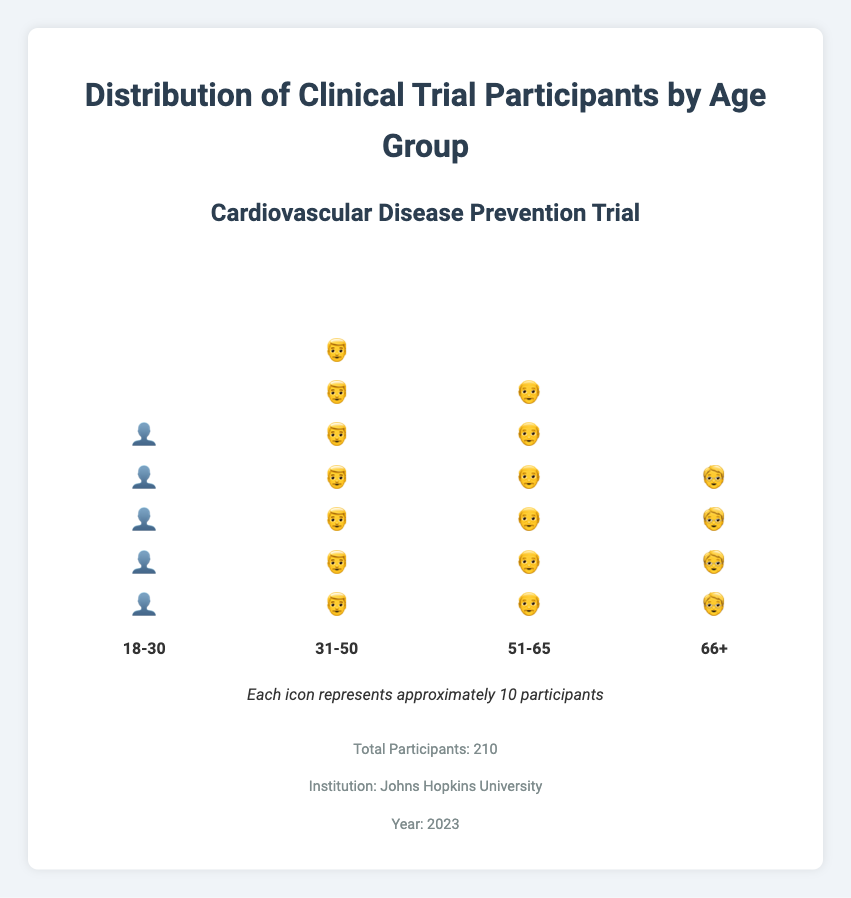What is the title of the figure? The title of the figure is located at the top and is clearly indicated by larger and bold text.
Answer: Distribution of Clinical Trial Participants by Age Group Which institution conducted the study? The information about the institution is provided at the bottom of the figure in the study info section.
Answer: Johns Hopkins University How many age groups are represented in the figure? By counting the distinct sets of icons and group labels at the bottom, you can see there are four age groups.
Answer: Four What icon represents the 31-50 age group? By looking at the icon within the stack under the 31-50 label, the icon representing this group is a human figure with the appearance of an adult male.
Answer: 👨 Which age group has the highest number of participants? Observing the tallest stack of icons and referring to the group label, the 31-50 age group has the highest number of icons.
Answer: 31-50 What is the total number of participants in the age group 18-30? The legend indicates each icon represents about 10 participants. Counting the 18-30 icons (5), each representing about 10, gives a total.
Answer: 50 How many more participants are there in the group 31-50 compared to the group 66+? The 31-50 group has 72 participants, and the 66+ group has 35 participants. The difference is calculated as 72 - 35.
Answer: 37 What percentage of participants are in the group 51-65? Divide the number of participants in the 51-65 group (58) by the total participants (210) and multiply by 100 to get the percentage.
Answer: 27.62% How does the number of participants in the 18-30 group compare to the 51-65 group? The 18-30 group has 45 participants, while the 51-65 group has 58 participants. Comparing the counts, the 51-65 group has more participants than the 18-30 group.
Answer: The 51-65 group has more How many icons are used to represent the participants in the 66+ age group? According to the data, the 66+ group has 35 participants. As each icon represents approximately 10 participants, 35/10 gives about 4 icons.
Answer: 4 